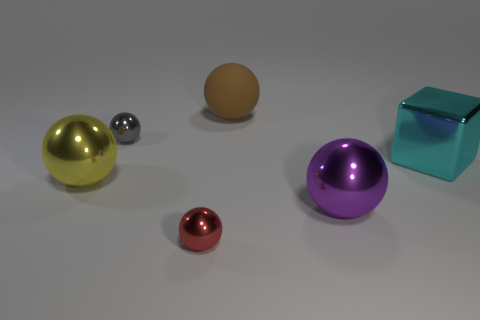Subtract 1 balls. How many balls are left? 4 Subtract all purple spheres. How many spheres are left? 4 Subtract all brown rubber spheres. How many spheres are left? 4 Subtract all cyan balls. Subtract all cyan cylinders. How many balls are left? 5 Add 3 blue cylinders. How many objects exist? 9 Subtract all balls. How many objects are left? 1 Subtract 1 red spheres. How many objects are left? 5 Subtract all red matte spheres. Subtract all small red spheres. How many objects are left? 5 Add 4 objects. How many objects are left? 10 Add 5 big blue shiny balls. How many big blue shiny balls exist? 5 